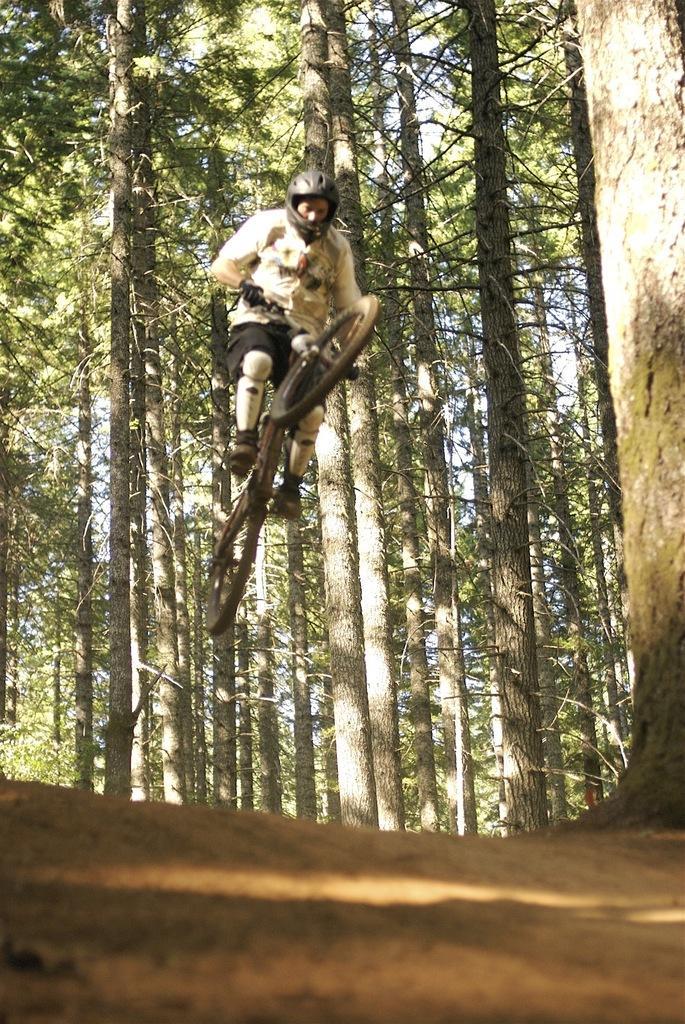Could you give a brief overview of what you see in this image? In the image there is a man on bicycle doing stunts. In background it's all trees. 